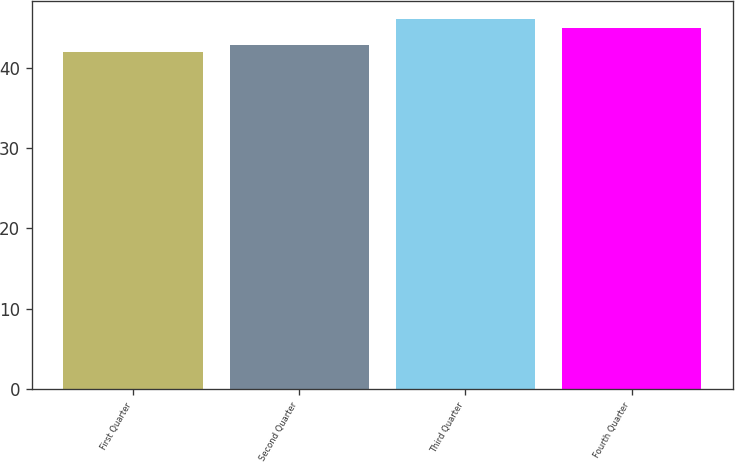<chart> <loc_0><loc_0><loc_500><loc_500><bar_chart><fcel>First Quarter<fcel>Second Quarter<fcel>Third Quarter<fcel>Fourth Quarter<nl><fcel>41.93<fcel>42.81<fcel>46.02<fcel>44.91<nl></chart> 